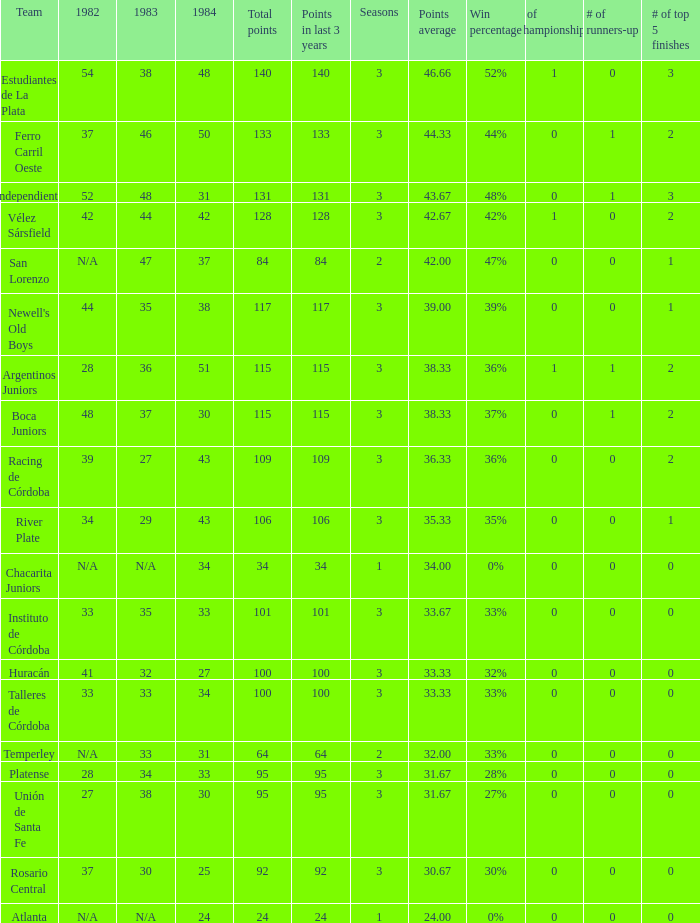What is the total for 1984 for the team with 100 points total and more than 3 seasons? None. 